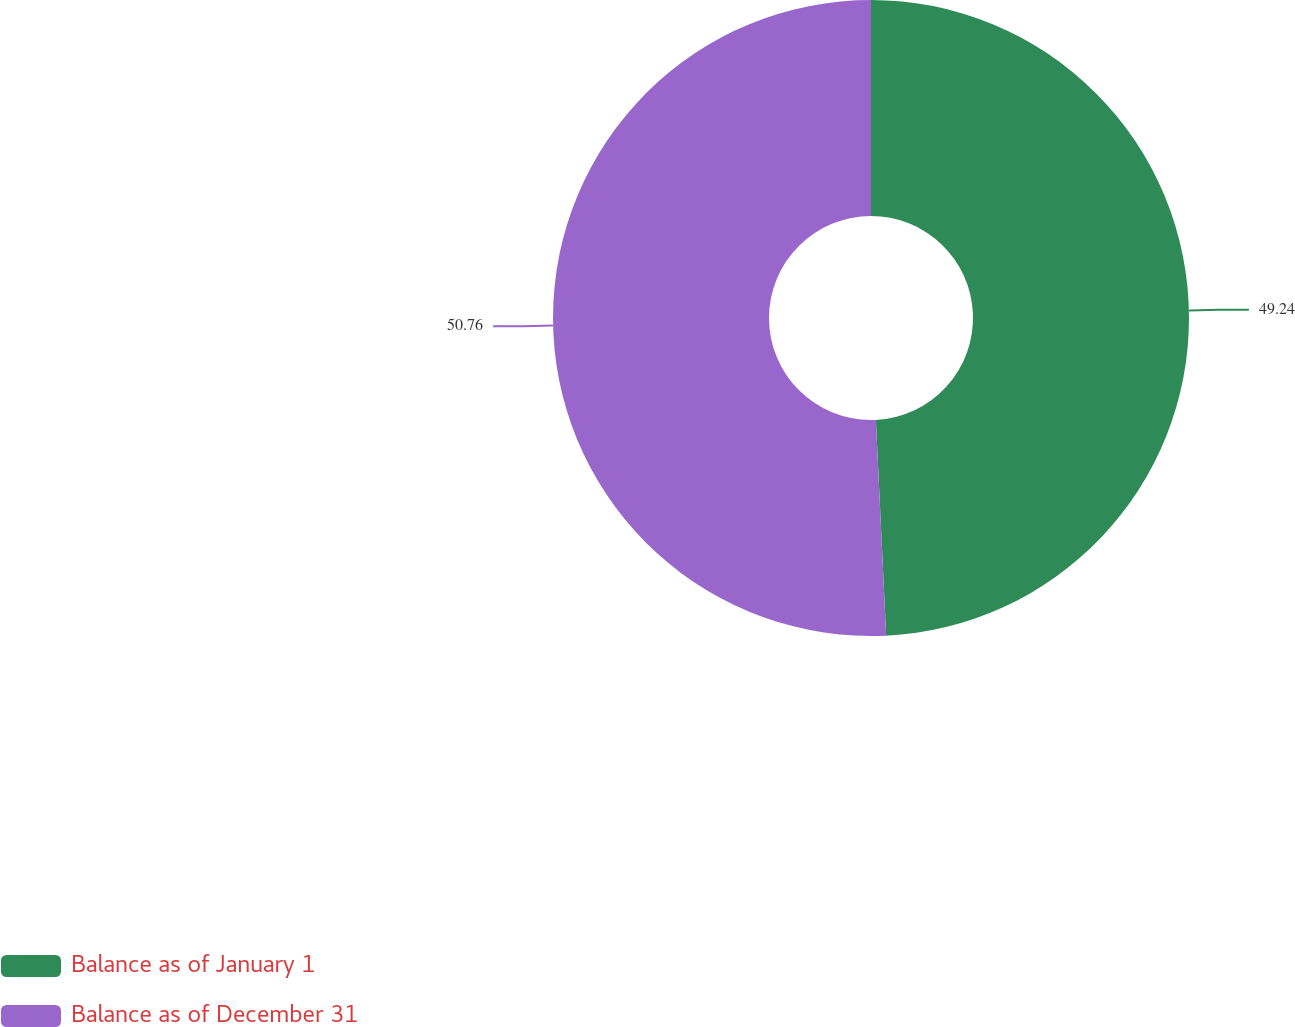Convert chart. <chart><loc_0><loc_0><loc_500><loc_500><pie_chart><fcel>Balance as of January 1<fcel>Balance as of December 31<nl><fcel>49.24%<fcel>50.76%<nl></chart> 